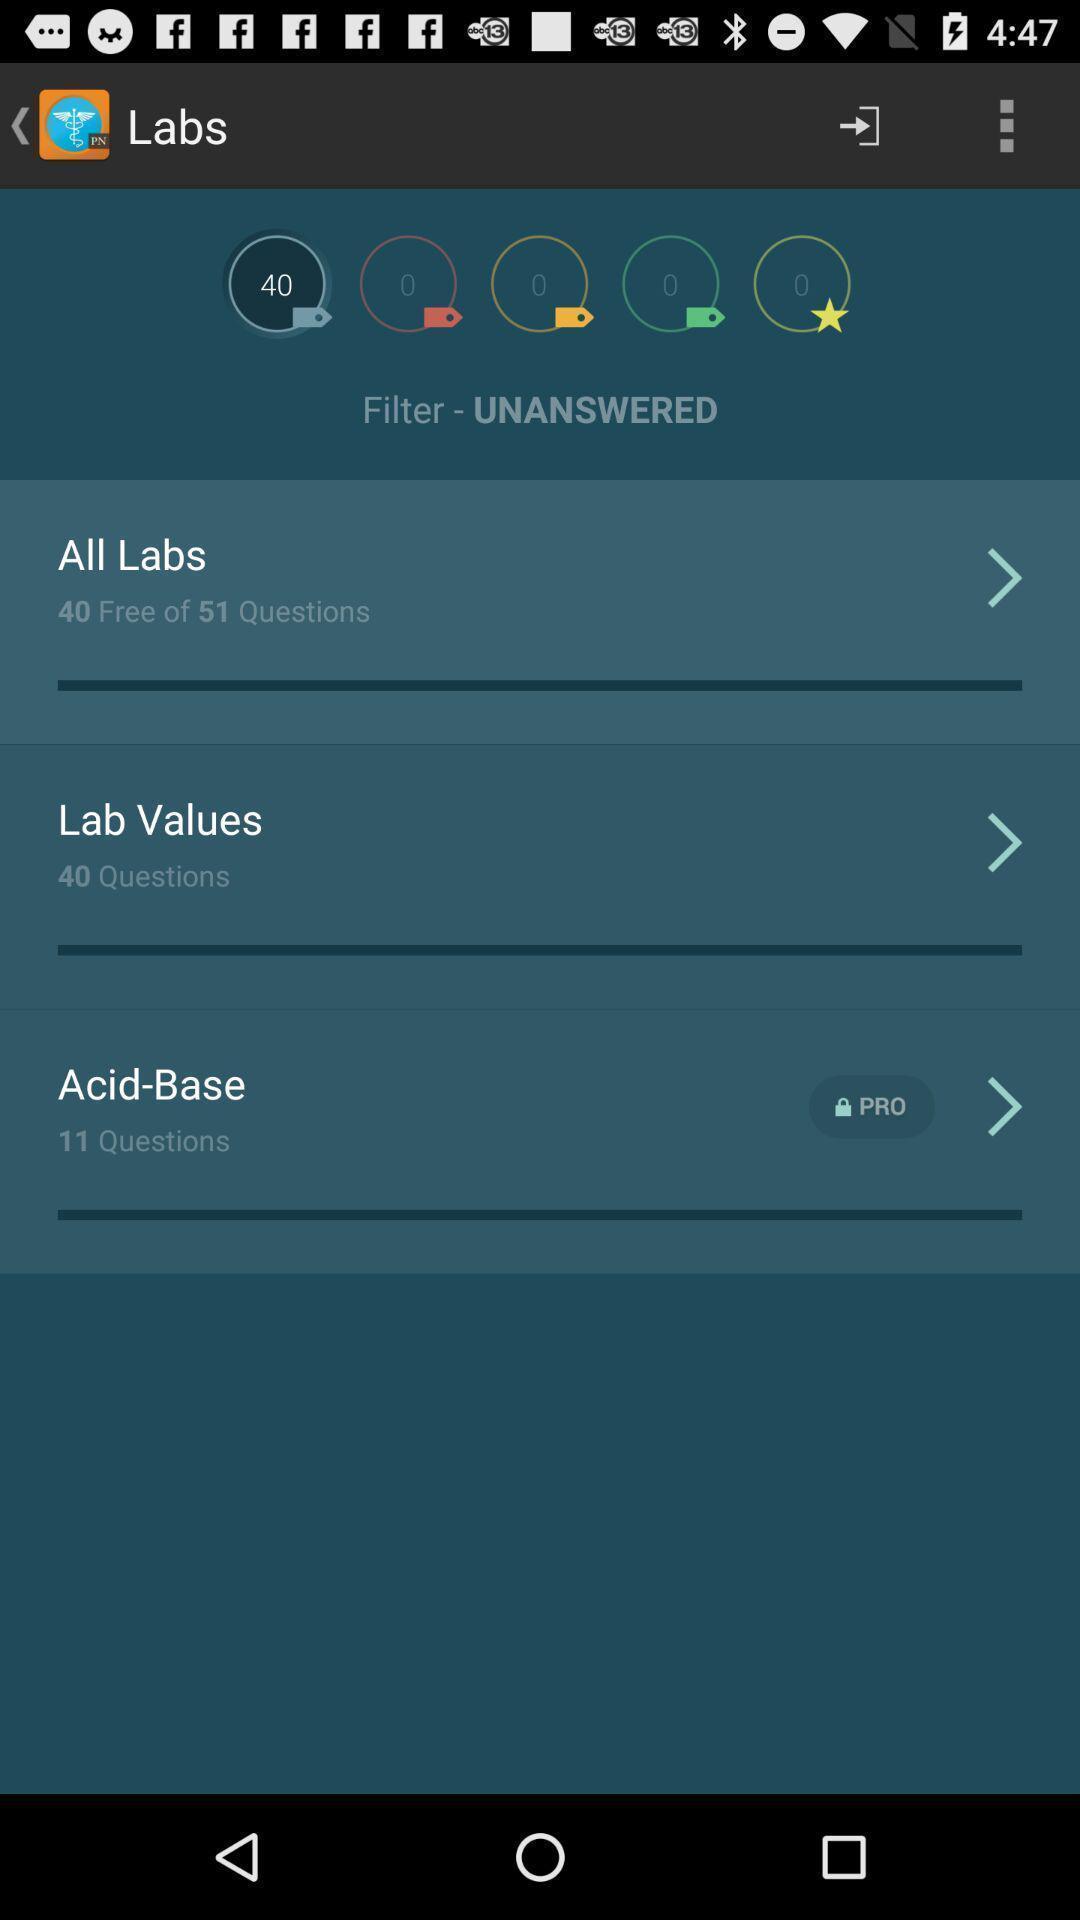Summarize the main components in this picture. Page showing the options in leaning app. 